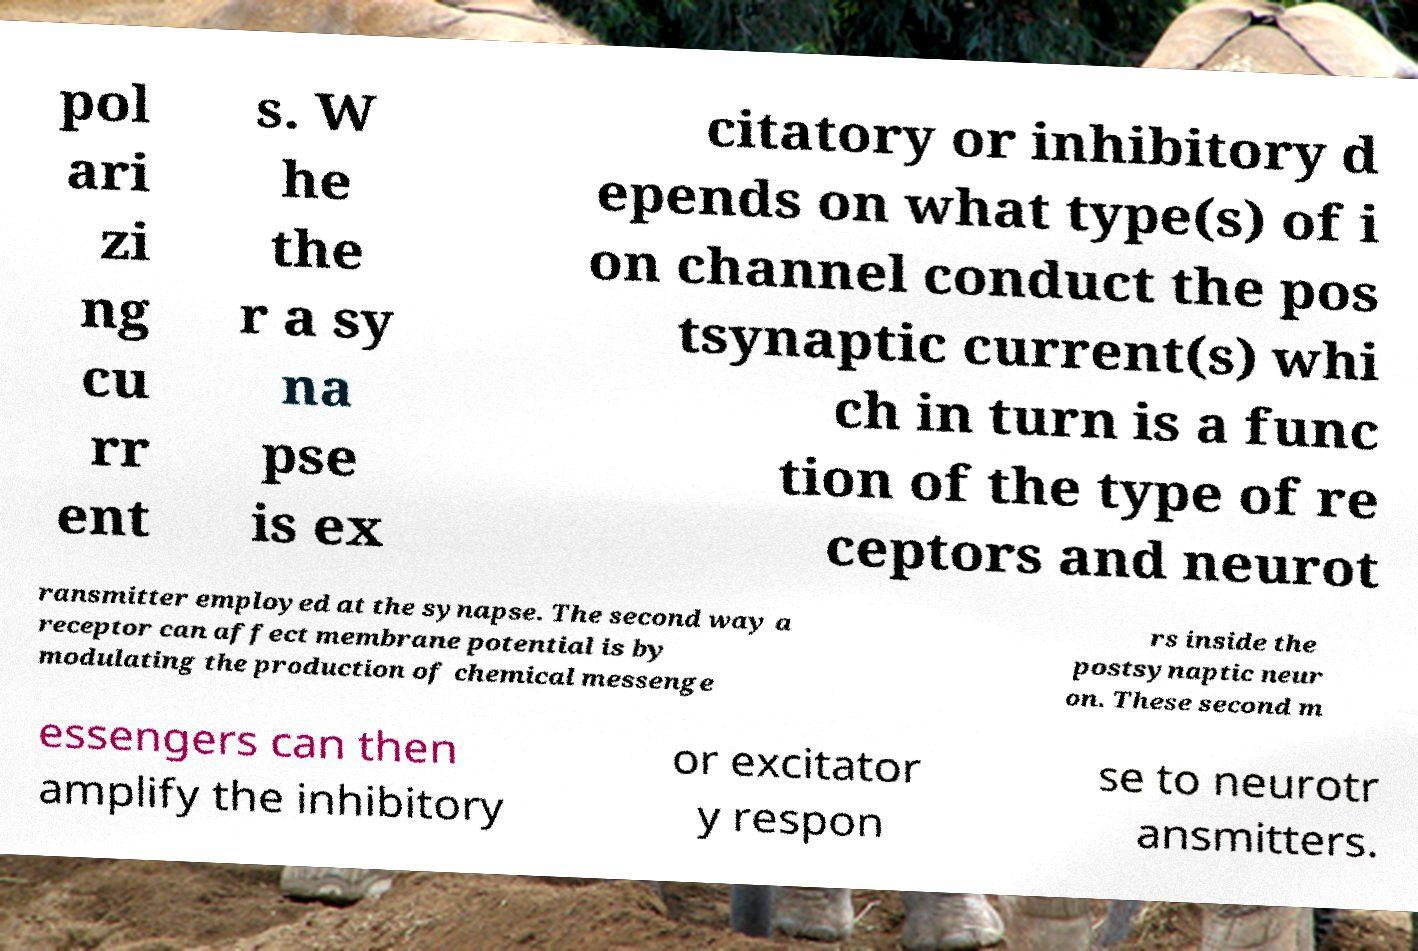Can you accurately transcribe the text from the provided image for me? pol ari zi ng cu rr ent s. W he the r a sy na pse is ex citatory or inhibitory d epends on what type(s) of i on channel conduct the pos tsynaptic current(s) whi ch in turn is a func tion of the type of re ceptors and neurot ransmitter employed at the synapse. The second way a receptor can affect membrane potential is by modulating the production of chemical messenge rs inside the postsynaptic neur on. These second m essengers can then amplify the inhibitory or excitator y respon se to neurotr ansmitters. 